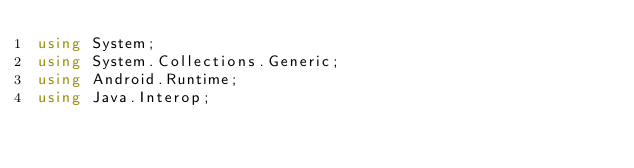<code> <loc_0><loc_0><loc_500><loc_500><_C#_>using System;
using System.Collections.Generic;
using Android.Runtime;
using Java.Interop;
</code> 